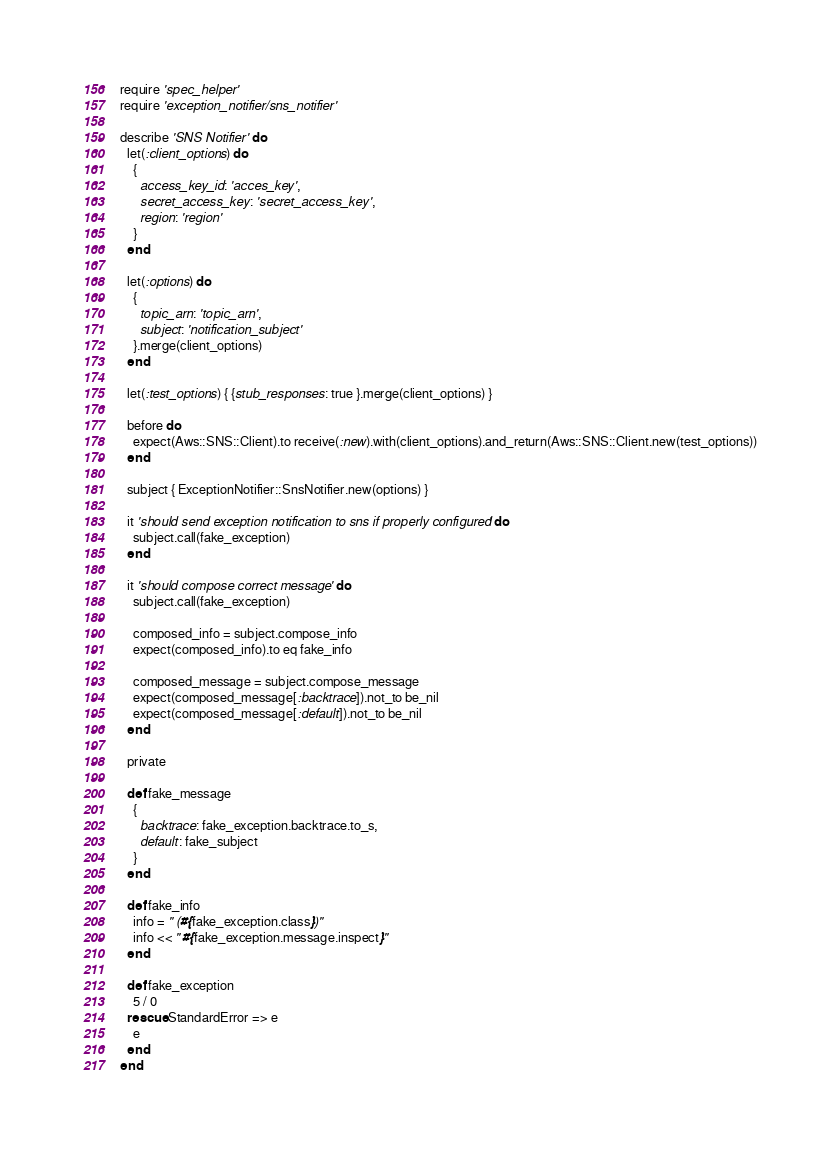<code> <loc_0><loc_0><loc_500><loc_500><_Ruby_>require 'spec_helper'
require 'exception_notifier/sns_notifier'

describe 'SNS Notifier' do
  let(:client_options) do
    {
      access_key_id: 'acces_key',
      secret_access_key: 'secret_access_key',
      region: 'region'
    }
  end

  let(:options) do
    {
      topic_arn: 'topic_arn',
      subject: 'notification_subject'
    }.merge(client_options)
  end

  let(:test_options) { {stub_responses: true }.merge(client_options) }

  before do
    expect(Aws::SNS::Client).to receive(:new).with(client_options).and_return(Aws::SNS::Client.new(test_options))
  end

  subject { ExceptionNotifier::SnsNotifier.new(options) }

  it 'should send exception notification to sns if properly configured' do
    subject.call(fake_exception)
  end

  it 'should compose correct message' do
    subject.call(fake_exception)

    composed_info = subject.compose_info
    expect(composed_info).to eq fake_info

    composed_message = subject.compose_message
    expect(composed_message[:backtrace]).not_to be_nil
    expect(composed_message[:default]).not_to be_nil
  end

  private

  def fake_message
    {
      backtrace: fake_exception.backtrace.to_s,
      default: fake_subject
    }
  end

  def fake_info
    info = " (#{fake_exception.class})"
    info << " #{fake_exception.message.inspect}"
  end

  def fake_exception
    5 / 0
  rescue StandardError => e
    e
  end
end
</code> 